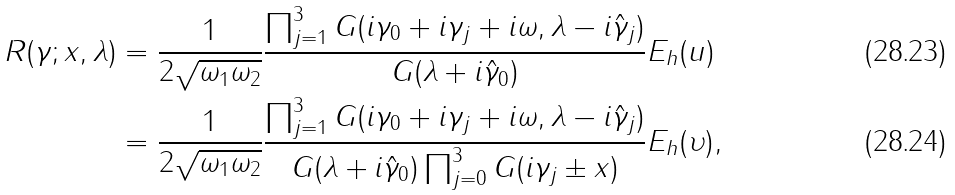<formula> <loc_0><loc_0><loc_500><loc_500>R ( \gamma ; x , \lambda ) & = \frac { 1 } { 2 \sqrt { \omega _ { 1 } \omega _ { 2 } } } \frac { \prod _ { j = 1 } ^ { 3 } G ( i \gamma _ { 0 } + i \gamma _ { j } + i \omega , \lambda - i \hat { \gamma } _ { j } ) } { G ( \lambda + i \hat { \gamma } _ { 0 } ) } E _ { h } ( u ) \\ & = \frac { 1 } { 2 \sqrt { \omega _ { 1 } \omega _ { 2 } } } \frac { \prod _ { j = 1 } ^ { 3 } G ( i \gamma _ { 0 } + i \gamma _ { j } + i \omega , \lambda - i \hat { \gamma } _ { j } ) } { G ( \lambda + i \hat { \gamma } _ { 0 } ) \prod _ { j = 0 } ^ { 3 } G ( i \gamma _ { j } \pm x ) } E _ { h } ( \upsilon ) ,</formula> 